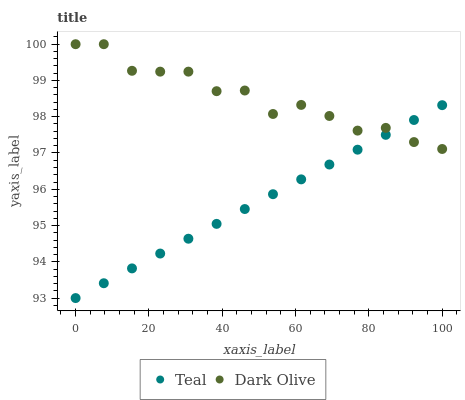Does Teal have the minimum area under the curve?
Answer yes or no. Yes. Does Dark Olive have the maximum area under the curve?
Answer yes or no. Yes. Does Teal have the maximum area under the curve?
Answer yes or no. No. Is Teal the smoothest?
Answer yes or no. Yes. Is Dark Olive the roughest?
Answer yes or no. Yes. Is Teal the roughest?
Answer yes or no. No. Does Teal have the lowest value?
Answer yes or no. Yes. Does Dark Olive have the highest value?
Answer yes or no. Yes. Does Teal have the highest value?
Answer yes or no. No. Does Dark Olive intersect Teal?
Answer yes or no. Yes. Is Dark Olive less than Teal?
Answer yes or no. No. Is Dark Olive greater than Teal?
Answer yes or no. No. 